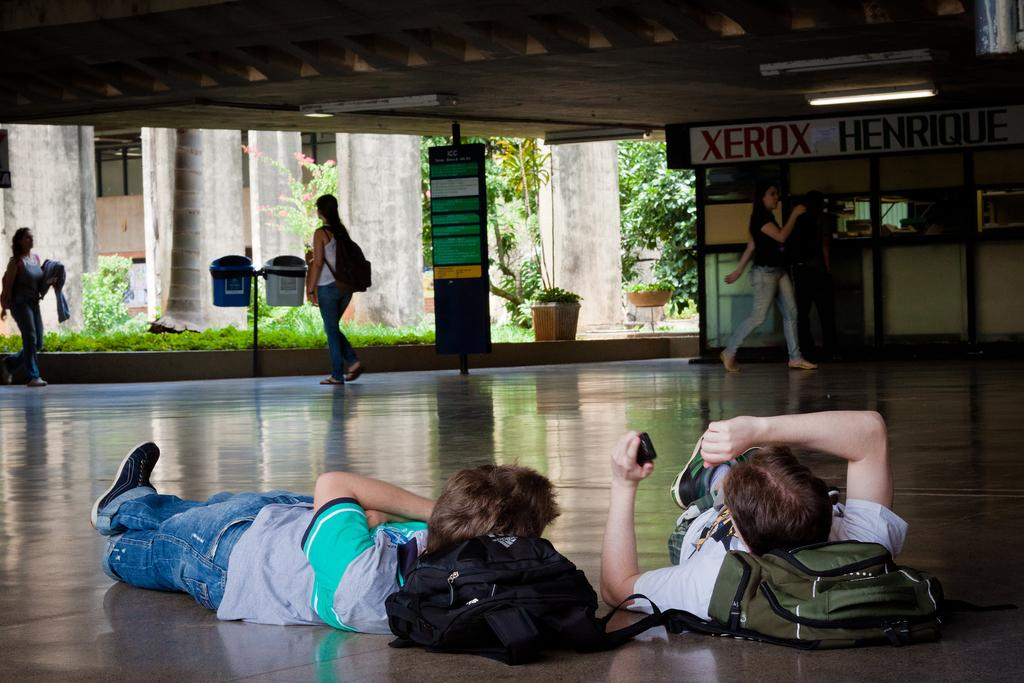<image>
Create a compact narrative representing the image presented. Two people sleep on the floor with the word Xerox visible. 